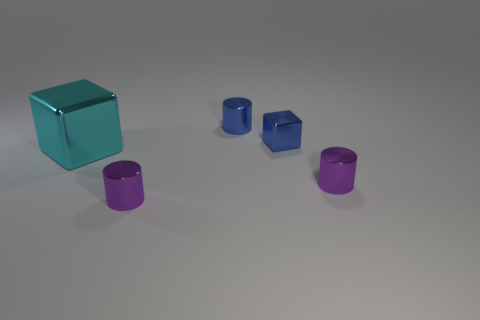What is the shape of the tiny metal thing that is the same color as the tiny metal block?
Offer a very short reply. Cylinder. What is the color of the small cube?
Your answer should be very brief. Blue. Are there any large blue balls that have the same material as the blue cylinder?
Keep it short and to the point. No. There is a small cylinder on the right side of the cylinder that is behind the big metal thing; are there any blue metal blocks on the right side of it?
Keep it short and to the point. No. There is a cyan metallic thing; are there any things behind it?
Your answer should be compact. Yes. Is there a shiny thing of the same color as the tiny shiny cube?
Provide a short and direct response. Yes. What number of small objects are either blocks or blue metallic objects?
Your answer should be very brief. 2. Is the material of the tiny cylinder that is behind the cyan cube the same as the big cyan cube?
Ensure brevity in your answer.  Yes. There is a tiny blue thing in front of the small metal cylinder behind the cyan cube in front of the small blue cube; what shape is it?
Offer a very short reply. Cube. How many blue things are large metallic blocks or tiny cylinders?
Your response must be concise. 1. 